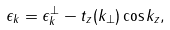Convert formula to latex. <formula><loc_0><loc_0><loc_500><loc_500>\epsilon _ { k } = \epsilon _ { k } ^ { \perp } - t _ { z } ( { k } _ { \perp } ) \cos k _ { z } ,</formula> 